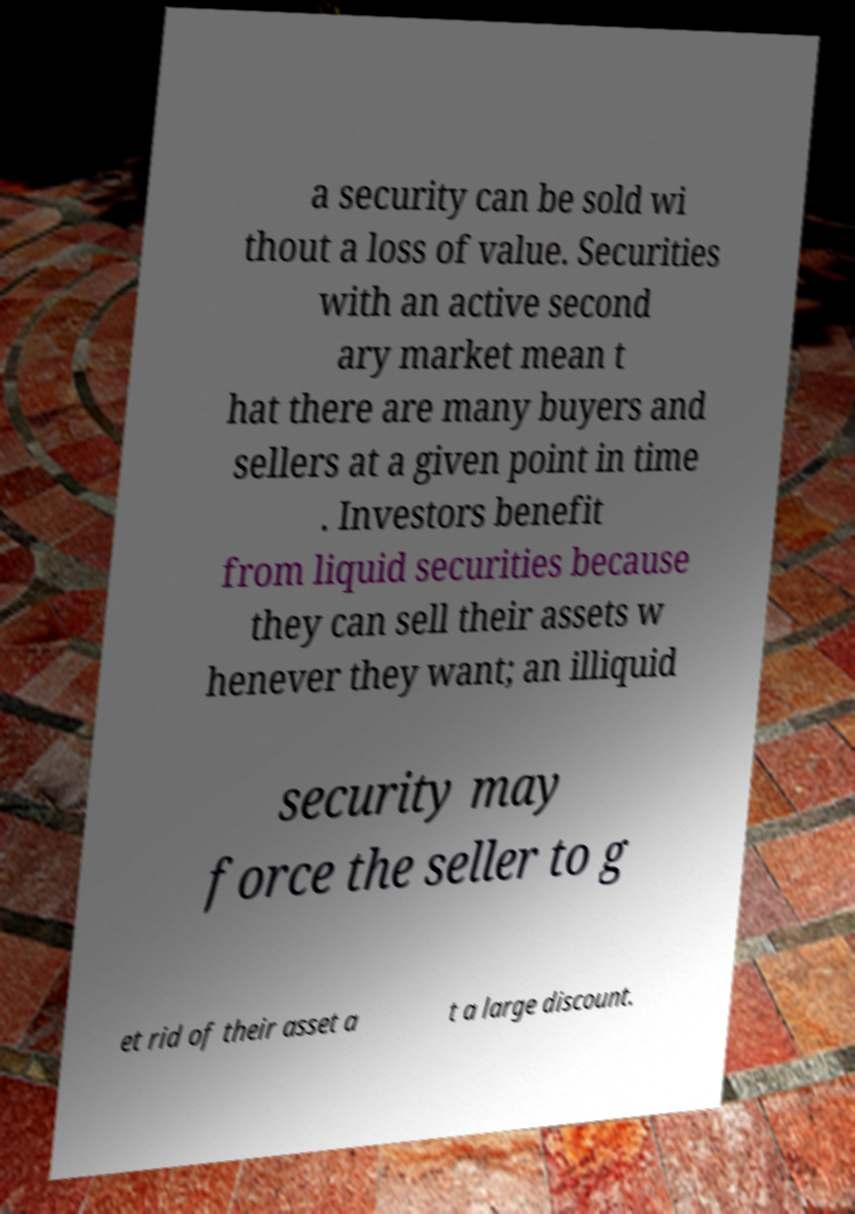I need the written content from this picture converted into text. Can you do that? a security can be sold wi thout a loss of value. Securities with an active second ary market mean t hat there are many buyers and sellers at a given point in time . Investors benefit from liquid securities because they can sell their assets w henever they want; an illiquid security may force the seller to g et rid of their asset a t a large discount. 